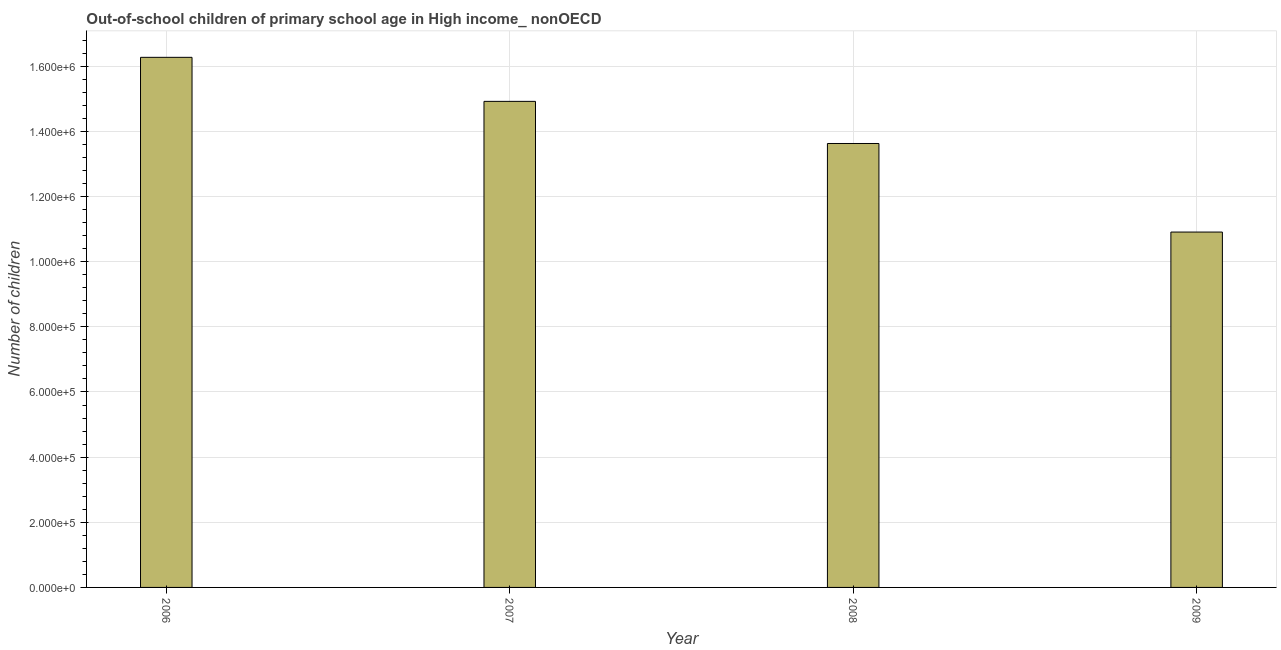Does the graph contain any zero values?
Your answer should be very brief. No. What is the title of the graph?
Provide a short and direct response. Out-of-school children of primary school age in High income_ nonOECD. What is the label or title of the X-axis?
Make the answer very short. Year. What is the label or title of the Y-axis?
Offer a very short reply. Number of children. What is the number of out-of-school children in 2007?
Ensure brevity in your answer.  1.49e+06. Across all years, what is the maximum number of out-of-school children?
Provide a succinct answer. 1.63e+06. Across all years, what is the minimum number of out-of-school children?
Ensure brevity in your answer.  1.09e+06. What is the sum of the number of out-of-school children?
Keep it short and to the point. 5.57e+06. What is the difference between the number of out-of-school children in 2006 and 2008?
Ensure brevity in your answer.  2.64e+05. What is the average number of out-of-school children per year?
Keep it short and to the point. 1.39e+06. What is the median number of out-of-school children?
Make the answer very short. 1.43e+06. What is the ratio of the number of out-of-school children in 2006 to that in 2007?
Provide a succinct answer. 1.09. Is the difference between the number of out-of-school children in 2007 and 2008 greater than the difference between any two years?
Offer a terse response. No. What is the difference between the highest and the second highest number of out-of-school children?
Offer a very short reply. 1.35e+05. What is the difference between the highest and the lowest number of out-of-school children?
Your answer should be very brief. 5.36e+05. How many bars are there?
Keep it short and to the point. 4. Are all the bars in the graph horizontal?
Keep it short and to the point. No. Are the values on the major ticks of Y-axis written in scientific E-notation?
Keep it short and to the point. Yes. What is the Number of children of 2006?
Provide a short and direct response. 1.63e+06. What is the Number of children of 2007?
Provide a short and direct response. 1.49e+06. What is the Number of children of 2008?
Make the answer very short. 1.36e+06. What is the Number of children in 2009?
Provide a short and direct response. 1.09e+06. What is the difference between the Number of children in 2006 and 2007?
Keep it short and to the point. 1.35e+05. What is the difference between the Number of children in 2006 and 2008?
Keep it short and to the point. 2.64e+05. What is the difference between the Number of children in 2006 and 2009?
Ensure brevity in your answer.  5.36e+05. What is the difference between the Number of children in 2007 and 2008?
Provide a short and direct response. 1.29e+05. What is the difference between the Number of children in 2007 and 2009?
Provide a succinct answer. 4.01e+05. What is the difference between the Number of children in 2008 and 2009?
Make the answer very short. 2.72e+05. What is the ratio of the Number of children in 2006 to that in 2007?
Keep it short and to the point. 1.09. What is the ratio of the Number of children in 2006 to that in 2008?
Provide a succinct answer. 1.19. What is the ratio of the Number of children in 2006 to that in 2009?
Your answer should be very brief. 1.49. What is the ratio of the Number of children in 2007 to that in 2008?
Your answer should be compact. 1.09. What is the ratio of the Number of children in 2007 to that in 2009?
Your answer should be very brief. 1.37. What is the ratio of the Number of children in 2008 to that in 2009?
Give a very brief answer. 1.25. 